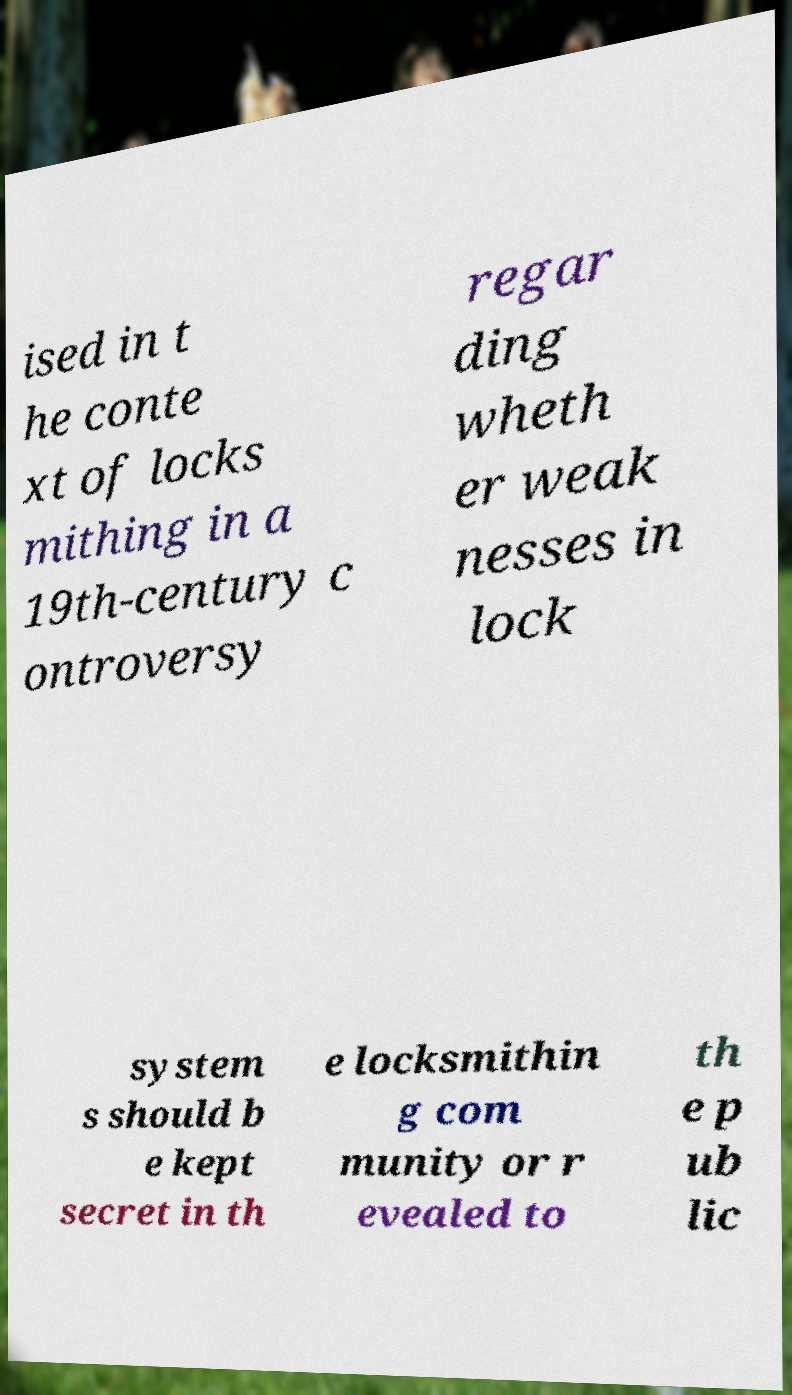Please read and relay the text visible in this image. What does it say? ised in t he conte xt of locks mithing in a 19th-century c ontroversy regar ding wheth er weak nesses in lock system s should b e kept secret in th e locksmithin g com munity or r evealed to th e p ub lic 